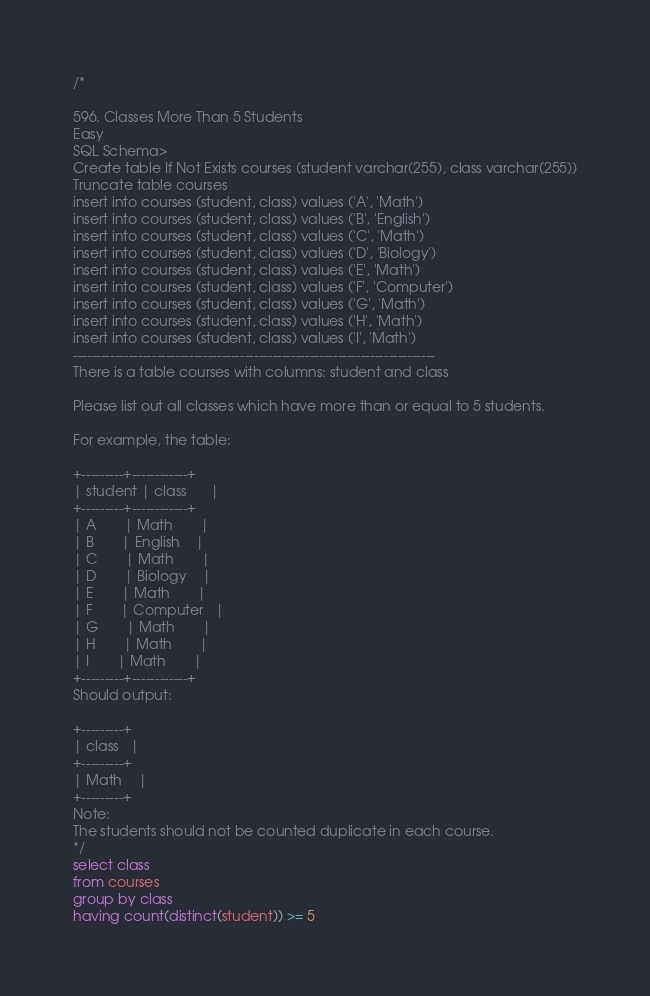<code> <loc_0><loc_0><loc_500><loc_500><_SQL_>/*

596. Classes More Than 5 Students
Easy
SQL Schema>
Create table If Not Exists courses (student varchar(255), class varchar(255))
Truncate table courses
insert into courses (student, class) values ('A', 'Math')
insert into courses (student, class) values ('B', 'English')
insert into courses (student, class) values ('C', 'Math')
insert into courses (student, class) values ('D', 'Biology')
insert into courses (student, class) values ('E', 'Math')
insert into courses (student, class) values ('F', 'Computer')
insert into courses (student, class) values ('G', 'Math')
insert into courses (student, class) values ('H', 'Math')
insert into courses (student, class) values ('I', 'Math')
------------------------------------------------------------------------------
There is a table courses with columns: student and class

Please list out all classes which have more than or equal to 5 students.

For example, the table:

+---------+------------+
| student | class      |
+---------+------------+
| A       | Math       |
| B       | English    |
| C       | Math       |
| D       | Biology    |
| E       | Math       |
| F       | Computer   |
| G       | Math       |
| H       | Math       |
| I       | Math       |
+---------+------------+
Should output:

+---------+
| class   |
+---------+
| Math    |
+---------+
Note:
The students should not be counted duplicate in each course.
*/
select class 
from courses
group by class
having count(distinct(student)) >= 5</code> 